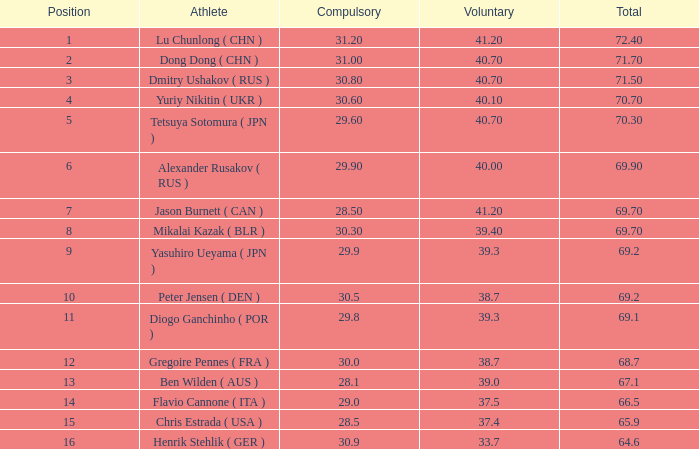Write the full table. {'header': ['Position', 'Athlete', 'Compulsory', 'Voluntary', 'Total'], 'rows': [['1', 'Lu Chunlong ( CHN )', '31.20', '41.20', '72.40'], ['2', 'Dong Dong ( CHN )', '31.00', '40.70', '71.70'], ['3', 'Dmitry Ushakov ( RUS )', '30.80', '40.70', '71.50'], ['4', 'Yuriy Nikitin ( UKR )', '30.60', '40.10', '70.70'], ['5', 'Tetsuya Sotomura ( JPN )', '29.60', '40.70', '70.30'], ['6', 'Alexander Rusakov ( RUS )', '29.90', '40.00', '69.90'], ['7', 'Jason Burnett ( CAN )', '28.50', '41.20', '69.70'], ['8', 'Mikalai Kazak ( BLR )', '30.30', '39.40', '69.70'], ['9', 'Yasuhiro Ueyama ( JPN )', '29.9', '39.3', '69.2'], ['10', 'Peter Jensen ( DEN )', '30.5', '38.7', '69.2'], ['11', 'Diogo Ganchinho ( POR )', '29.8', '39.3', '69.1'], ['12', 'Gregoire Pennes ( FRA )', '30.0', '38.7', '68.7'], ['13', 'Ben Wilden ( AUS )', '28.1', '39.0', '67.1'], ['14', 'Flavio Cannone ( ITA )', '29.0', '37.5', '66.5'], ['15', 'Chris Estrada ( USA )', '28.5', '37.4', '65.9'], ['16', 'Henrik Stehlik ( GER )', '30.9', '33.7', '64.6']]} 7? None. 